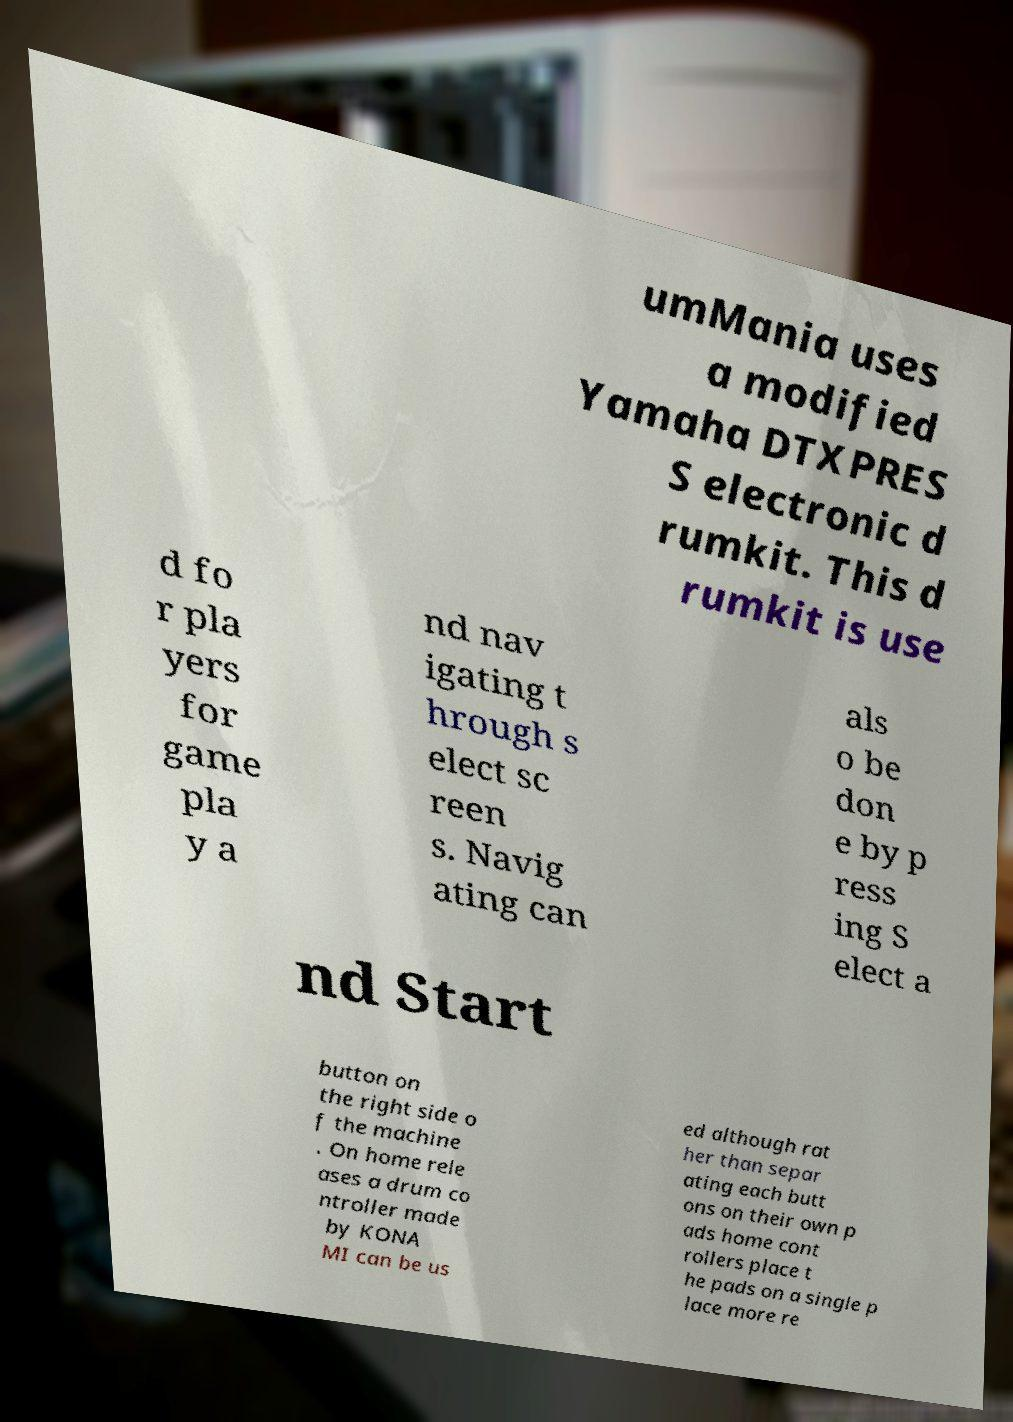Could you extract and type out the text from this image? umMania uses a modified Yamaha DTXPRES S electronic d rumkit. This d rumkit is use d fo r pla yers for game pla y a nd nav igating t hrough s elect sc reen s. Navig ating can als o be don e by p ress ing S elect a nd Start button on the right side o f the machine . On home rele ases a drum co ntroller made by KONA MI can be us ed although rat her than separ ating each butt ons on their own p ads home cont rollers place t he pads on a single p lace more re 